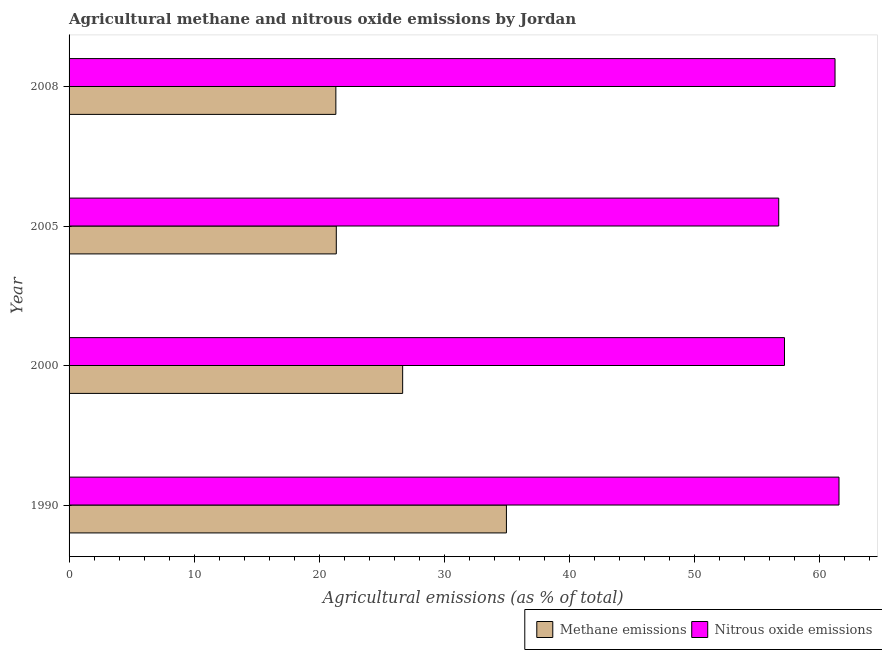Are the number of bars per tick equal to the number of legend labels?
Your answer should be compact. Yes. How many bars are there on the 1st tick from the bottom?
Your answer should be very brief. 2. What is the amount of methane emissions in 2005?
Your answer should be compact. 21.37. Across all years, what is the maximum amount of nitrous oxide emissions?
Offer a very short reply. 61.58. Across all years, what is the minimum amount of methane emissions?
Make the answer very short. 21.34. In which year was the amount of methane emissions maximum?
Offer a very short reply. 1990. What is the total amount of methane emissions in the graph?
Your response must be concise. 104.37. What is the difference between the amount of nitrous oxide emissions in 1990 and that in 2005?
Provide a short and direct response. 4.82. What is the difference between the amount of methane emissions in 2000 and the amount of nitrous oxide emissions in 2005?
Your answer should be compact. -30.08. What is the average amount of nitrous oxide emissions per year?
Provide a short and direct response. 59.2. In the year 2008, what is the difference between the amount of nitrous oxide emissions and amount of methane emissions?
Your answer should be compact. 39.92. In how many years, is the amount of methane emissions greater than 22 %?
Offer a very short reply. 2. What is the ratio of the amount of nitrous oxide emissions in 2000 to that in 2008?
Provide a short and direct response. 0.93. Is the amount of methane emissions in 1990 less than that in 2005?
Provide a short and direct response. No. Is the difference between the amount of nitrous oxide emissions in 1990 and 2005 greater than the difference between the amount of methane emissions in 1990 and 2005?
Offer a terse response. No. What is the difference between the highest and the second highest amount of methane emissions?
Give a very brief answer. 8.3. What is the difference between the highest and the lowest amount of nitrous oxide emissions?
Your answer should be compact. 4.82. What does the 1st bar from the top in 1990 represents?
Give a very brief answer. Nitrous oxide emissions. What does the 2nd bar from the bottom in 2000 represents?
Provide a short and direct response. Nitrous oxide emissions. Are all the bars in the graph horizontal?
Your answer should be compact. Yes. How many years are there in the graph?
Ensure brevity in your answer.  4. What is the difference between two consecutive major ticks on the X-axis?
Your response must be concise. 10. Are the values on the major ticks of X-axis written in scientific E-notation?
Keep it short and to the point. No. Where does the legend appear in the graph?
Your answer should be compact. Bottom right. How are the legend labels stacked?
Provide a short and direct response. Horizontal. What is the title of the graph?
Provide a succinct answer. Agricultural methane and nitrous oxide emissions by Jordan. What is the label or title of the X-axis?
Keep it short and to the point. Agricultural emissions (as % of total). What is the Agricultural emissions (as % of total) of Methane emissions in 1990?
Your response must be concise. 34.98. What is the Agricultural emissions (as % of total) in Nitrous oxide emissions in 1990?
Your answer should be very brief. 61.58. What is the Agricultural emissions (as % of total) of Methane emissions in 2000?
Offer a terse response. 26.68. What is the Agricultural emissions (as % of total) of Nitrous oxide emissions in 2000?
Ensure brevity in your answer.  57.22. What is the Agricultural emissions (as % of total) of Methane emissions in 2005?
Your answer should be compact. 21.37. What is the Agricultural emissions (as % of total) in Nitrous oxide emissions in 2005?
Give a very brief answer. 56.76. What is the Agricultural emissions (as % of total) of Methane emissions in 2008?
Provide a succinct answer. 21.34. What is the Agricultural emissions (as % of total) in Nitrous oxide emissions in 2008?
Offer a terse response. 61.26. Across all years, what is the maximum Agricultural emissions (as % of total) in Methane emissions?
Your response must be concise. 34.98. Across all years, what is the maximum Agricultural emissions (as % of total) in Nitrous oxide emissions?
Your response must be concise. 61.58. Across all years, what is the minimum Agricultural emissions (as % of total) of Methane emissions?
Provide a succinct answer. 21.34. Across all years, what is the minimum Agricultural emissions (as % of total) of Nitrous oxide emissions?
Give a very brief answer. 56.76. What is the total Agricultural emissions (as % of total) in Methane emissions in the graph?
Your answer should be compact. 104.37. What is the total Agricultural emissions (as % of total) of Nitrous oxide emissions in the graph?
Provide a short and direct response. 236.82. What is the difference between the Agricultural emissions (as % of total) of Methane emissions in 1990 and that in 2000?
Your answer should be compact. 8.3. What is the difference between the Agricultural emissions (as % of total) in Nitrous oxide emissions in 1990 and that in 2000?
Make the answer very short. 4.36. What is the difference between the Agricultural emissions (as % of total) in Methane emissions in 1990 and that in 2005?
Give a very brief answer. 13.61. What is the difference between the Agricultural emissions (as % of total) in Nitrous oxide emissions in 1990 and that in 2005?
Provide a short and direct response. 4.82. What is the difference between the Agricultural emissions (as % of total) of Methane emissions in 1990 and that in 2008?
Your response must be concise. 13.64. What is the difference between the Agricultural emissions (as % of total) in Nitrous oxide emissions in 1990 and that in 2008?
Offer a very short reply. 0.32. What is the difference between the Agricultural emissions (as % of total) of Methane emissions in 2000 and that in 2005?
Provide a short and direct response. 5.31. What is the difference between the Agricultural emissions (as % of total) of Nitrous oxide emissions in 2000 and that in 2005?
Provide a short and direct response. 0.46. What is the difference between the Agricultural emissions (as % of total) in Methane emissions in 2000 and that in 2008?
Keep it short and to the point. 5.34. What is the difference between the Agricultural emissions (as % of total) in Nitrous oxide emissions in 2000 and that in 2008?
Make the answer very short. -4.04. What is the difference between the Agricultural emissions (as % of total) in Methane emissions in 2005 and that in 2008?
Provide a short and direct response. 0.04. What is the difference between the Agricultural emissions (as % of total) in Nitrous oxide emissions in 2005 and that in 2008?
Keep it short and to the point. -4.5. What is the difference between the Agricultural emissions (as % of total) in Methane emissions in 1990 and the Agricultural emissions (as % of total) in Nitrous oxide emissions in 2000?
Your response must be concise. -22.24. What is the difference between the Agricultural emissions (as % of total) of Methane emissions in 1990 and the Agricultural emissions (as % of total) of Nitrous oxide emissions in 2005?
Give a very brief answer. -21.78. What is the difference between the Agricultural emissions (as % of total) in Methane emissions in 1990 and the Agricultural emissions (as % of total) in Nitrous oxide emissions in 2008?
Ensure brevity in your answer.  -26.28. What is the difference between the Agricultural emissions (as % of total) in Methane emissions in 2000 and the Agricultural emissions (as % of total) in Nitrous oxide emissions in 2005?
Keep it short and to the point. -30.08. What is the difference between the Agricultural emissions (as % of total) of Methane emissions in 2000 and the Agricultural emissions (as % of total) of Nitrous oxide emissions in 2008?
Provide a short and direct response. -34.58. What is the difference between the Agricultural emissions (as % of total) of Methane emissions in 2005 and the Agricultural emissions (as % of total) of Nitrous oxide emissions in 2008?
Ensure brevity in your answer.  -39.89. What is the average Agricultural emissions (as % of total) of Methane emissions per year?
Make the answer very short. 26.09. What is the average Agricultural emissions (as % of total) of Nitrous oxide emissions per year?
Offer a very short reply. 59.2. In the year 1990, what is the difference between the Agricultural emissions (as % of total) of Methane emissions and Agricultural emissions (as % of total) of Nitrous oxide emissions?
Provide a succinct answer. -26.6. In the year 2000, what is the difference between the Agricultural emissions (as % of total) of Methane emissions and Agricultural emissions (as % of total) of Nitrous oxide emissions?
Offer a very short reply. -30.54. In the year 2005, what is the difference between the Agricultural emissions (as % of total) of Methane emissions and Agricultural emissions (as % of total) of Nitrous oxide emissions?
Provide a short and direct response. -35.39. In the year 2008, what is the difference between the Agricultural emissions (as % of total) of Methane emissions and Agricultural emissions (as % of total) of Nitrous oxide emissions?
Give a very brief answer. -39.92. What is the ratio of the Agricultural emissions (as % of total) of Methane emissions in 1990 to that in 2000?
Make the answer very short. 1.31. What is the ratio of the Agricultural emissions (as % of total) of Nitrous oxide emissions in 1990 to that in 2000?
Give a very brief answer. 1.08. What is the ratio of the Agricultural emissions (as % of total) in Methane emissions in 1990 to that in 2005?
Provide a short and direct response. 1.64. What is the ratio of the Agricultural emissions (as % of total) in Nitrous oxide emissions in 1990 to that in 2005?
Your answer should be compact. 1.08. What is the ratio of the Agricultural emissions (as % of total) of Methane emissions in 1990 to that in 2008?
Make the answer very short. 1.64. What is the ratio of the Agricultural emissions (as % of total) in Nitrous oxide emissions in 1990 to that in 2008?
Ensure brevity in your answer.  1.01. What is the ratio of the Agricultural emissions (as % of total) of Methane emissions in 2000 to that in 2005?
Your answer should be compact. 1.25. What is the ratio of the Agricultural emissions (as % of total) in Methane emissions in 2000 to that in 2008?
Make the answer very short. 1.25. What is the ratio of the Agricultural emissions (as % of total) in Nitrous oxide emissions in 2000 to that in 2008?
Ensure brevity in your answer.  0.93. What is the ratio of the Agricultural emissions (as % of total) in Nitrous oxide emissions in 2005 to that in 2008?
Give a very brief answer. 0.93. What is the difference between the highest and the second highest Agricultural emissions (as % of total) of Methane emissions?
Provide a succinct answer. 8.3. What is the difference between the highest and the second highest Agricultural emissions (as % of total) of Nitrous oxide emissions?
Offer a terse response. 0.32. What is the difference between the highest and the lowest Agricultural emissions (as % of total) in Methane emissions?
Your response must be concise. 13.64. What is the difference between the highest and the lowest Agricultural emissions (as % of total) of Nitrous oxide emissions?
Make the answer very short. 4.82. 